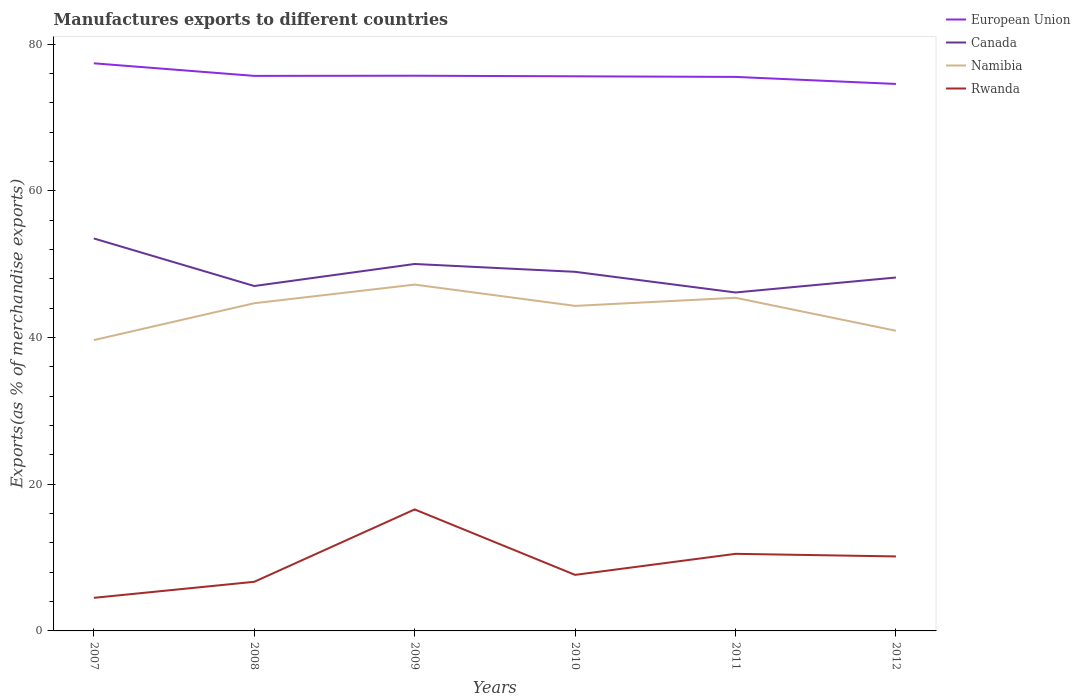How many different coloured lines are there?
Ensure brevity in your answer.  4. Does the line corresponding to Canada intersect with the line corresponding to Namibia?
Keep it short and to the point. No. Across all years, what is the maximum percentage of exports to different countries in Rwanda?
Your answer should be very brief. 4.51. What is the total percentage of exports to different countries in European Union in the graph?
Provide a short and direct response. 1.86. What is the difference between the highest and the second highest percentage of exports to different countries in Namibia?
Make the answer very short. 7.57. Is the percentage of exports to different countries in Canada strictly greater than the percentage of exports to different countries in European Union over the years?
Provide a succinct answer. Yes. Are the values on the major ticks of Y-axis written in scientific E-notation?
Provide a short and direct response. No. Does the graph contain any zero values?
Give a very brief answer. No. Does the graph contain grids?
Offer a terse response. No. Where does the legend appear in the graph?
Ensure brevity in your answer.  Top right. What is the title of the graph?
Ensure brevity in your answer.  Manufactures exports to different countries. Does "Euro area" appear as one of the legend labels in the graph?
Keep it short and to the point. No. What is the label or title of the X-axis?
Give a very brief answer. Years. What is the label or title of the Y-axis?
Give a very brief answer. Exports(as % of merchandise exports). What is the Exports(as % of merchandise exports) in European Union in 2007?
Offer a very short reply. 77.4. What is the Exports(as % of merchandise exports) in Canada in 2007?
Your answer should be compact. 53.52. What is the Exports(as % of merchandise exports) of Namibia in 2007?
Provide a short and direct response. 39.66. What is the Exports(as % of merchandise exports) of Rwanda in 2007?
Provide a short and direct response. 4.51. What is the Exports(as % of merchandise exports) in European Union in 2008?
Make the answer very short. 75.69. What is the Exports(as % of merchandise exports) in Canada in 2008?
Give a very brief answer. 47.03. What is the Exports(as % of merchandise exports) of Namibia in 2008?
Make the answer very short. 44.68. What is the Exports(as % of merchandise exports) in Rwanda in 2008?
Provide a succinct answer. 6.7. What is the Exports(as % of merchandise exports) in European Union in 2009?
Your response must be concise. 75.71. What is the Exports(as % of merchandise exports) in Canada in 2009?
Offer a very short reply. 50.04. What is the Exports(as % of merchandise exports) of Namibia in 2009?
Offer a very short reply. 47.22. What is the Exports(as % of merchandise exports) in Rwanda in 2009?
Your response must be concise. 16.57. What is the Exports(as % of merchandise exports) of European Union in 2010?
Offer a terse response. 75.63. What is the Exports(as % of merchandise exports) of Canada in 2010?
Offer a very short reply. 48.97. What is the Exports(as % of merchandise exports) in Namibia in 2010?
Your answer should be very brief. 44.32. What is the Exports(as % of merchandise exports) of Rwanda in 2010?
Provide a succinct answer. 7.64. What is the Exports(as % of merchandise exports) in European Union in 2011?
Offer a very short reply. 75.55. What is the Exports(as % of merchandise exports) in Canada in 2011?
Give a very brief answer. 46.15. What is the Exports(as % of merchandise exports) of Namibia in 2011?
Your response must be concise. 45.43. What is the Exports(as % of merchandise exports) in Rwanda in 2011?
Provide a short and direct response. 10.51. What is the Exports(as % of merchandise exports) in European Union in 2012?
Provide a succinct answer. 74.58. What is the Exports(as % of merchandise exports) of Canada in 2012?
Keep it short and to the point. 48.19. What is the Exports(as % of merchandise exports) of Namibia in 2012?
Provide a succinct answer. 40.93. What is the Exports(as % of merchandise exports) in Rwanda in 2012?
Provide a succinct answer. 10.16. Across all years, what is the maximum Exports(as % of merchandise exports) in European Union?
Offer a very short reply. 77.4. Across all years, what is the maximum Exports(as % of merchandise exports) of Canada?
Provide a short and direct response. 53.52. Across all years, what is the maximum Exports(as % of merchandise exports) in Namibia?
Offer a very short reply. 47.22. Across all years, what is the maximum Exports(as % of merchandise exports) in Rwanda?
Your answer should be very brief. 16.57. Across all years, what is the minimum Exports(as % of merchandise exports) of European Union?
Keep it short and to the point. 74.58. Across all years, what is the minimum Exports(as % of merchandise exports) in Canada?
Your answer should be compact. 46.15. Across all years, what is the minimum Exports(as % of merchandise exports) of Namibia?
Provide a short and direct response. 39.66. Across all years, what is the minimum Exports(as % of merchandise exports) of Rwanda?
Give a very brief answer. 4.51. What is the total Exports(as % of merchandise exports) in European Union in the graph?
Provide a succinct answer. 454.55. What is the total Exports(as % of merchandise exports) in Canada in the graph?
Offer a terse response. 293.9. What is the total Exports(as % of merchandise exports) of Namibia in the graph?
Offer a terse response. 262.24. What is the total Exports(as % of merchandise exports) of Rwanda in the graph?
Give a very brief answer. 56.09. What is the difference between the Exports(as % of merchandise exports) in European Union in 2007 and that in 2008?
Your answer should be compact. 1.72. What is the difference between the Exports(as % of merchandise exports) of Canada in 2007 and that in 2008?
Offer a very short reply. 6.49. What is the difference between the Exports(as % of merchandise exports) of Namibia in 2007 and that in 2008?
Your answer should be compact. -5.03. What is the difference between the Exports(as % of merchandise exports) in Rwanda in 2007 and that in 2008?
Give a very brief answer. -2.19. What is the difference between the Exports(as % of merchandise exports) of European Union in 2007 and that in 2009?
Keep it short and to the point. 1.69. What is the difference between the Exports(as % of merchandise exports) in Canada in 2007 and that in 2009?
Provide a short and direct response. 3.48. What is the difference between the Exports(as % of merchandise exports) of Namibia in 2007 and that in 2009?
Make the answer very short. -7.57. What is the difference between the Exports(as % of merchandise exports) in Rwanda in 2007 and that in 2009?
Offer a very short reply. -12.06. What is the difference between the Exports(as % of merchandise exports) of European Union in 2007 and that in 2010?
Provide a short and direct response. 1.77. What is the difference between the Exports(as % of merchandise exports) in Canada in 2007 and that in 2010?
Your answer should be compact. 4.55. What is the difference between the Exports(as % of merchandise exports) of Namibia in 2007 and that in 2010?
Offer a very short reply. -4.67. What is the difference between the Exports(as % of merchandise exports) in Rwanda in 2007 and that in 2010?
Make the answer very short. -3.13. What is the difference between the Exports(as % of merchandise exports) in European Union in 2007 and that in 2011?
Your answer should be compact. 1.86. What is the difference between the Exports(as % of merchandise exports) in Canada in 2007 and that in 2011?
Your response must be concise. 7.37. What is the difference between the Exports(as % of merchandise exports) of Namibia in 2007 and that in 2011?
Keep it short and to the point. -5.77. What is the difference between the Exports(as % of merchandise exports) of Rwanda in 2007 and that in 2011?
Your answer should be compact. -6. What is the difference between the Exports(as % of merchandise exports) in European Union in 2007 and that in 2012?
Ensure brevity in your answer.  2.82. What is the difference between the Exports(as % of merchandise exports) of Canada in 2007 and that in 2012?
Keep it short and to the point. 5.33. What is the difference between the Exports(as % of merchandise exports) in Namibia in 2007 and that in 2012?
Make the answer very short. -1.27. What is the difference between the Exports(as % of merchandise exports) of Rwanda in 2007 and that in 2012?
Ensure brevity in your answer.  -5.65. What is the difference between the Exports(as % of merchandise exports) of European Union in 2008 and that in 2009?
Keep it short and to the point. -0.02. What is the difference between the Exports(as % of merchandise exports) in Canada in 2008 and that in 2009?
Provide a short and direct response. -3. What is the difference between the Exports(as % of merchandise exports) of Namibia in 2008 and that in 2009?
Offer a very short reply. -2.54. What is the difference between the Exports(as % of merchandise exports) of Rwanda in 2008 and that in 2009?
Your answer should be very brief. -9.87. What is the difference between the Exports(as % of merchandise exports) in European Union in 2008 and that in 2010?
Your answer should be compact. 0.06. What is the difference between the Exports(as % of merchandise exports) of Canada in 2008 and that in 2010?
Offer a very short reply. -1.93. What is the difference between the Exports(as % of merchandise exports) of Namibia in 2008 and that in 2010?
Your answer should be very brief. 0.36. What is the difference between the Exports(as % of merchandise exports) of Rwanda in 2008 and that in 2010?
Give a very brief answer. -0.94. What is the difference between the Exports(as % of merchandise exports) of European Union in 2008 and that in 2011?
Give a very brief answer. 0.14. What is the difference between the Exports(as % of merchandise exports) of Canada in 2008 and that in 2011?
Your answer should be very brief. 0.88. What is the difference between the Exports(as % of merchandise exports) of Namibia in 2008 and that in 2011?
Make the answer very short. -0.74. What is the difference between the Exports(as % of merchandise exports) of Rwanda in 2008 and that in 2011?
Your answer should be compact. -3.81. What is the difference between the Exports(as % of merchandise exports) in European Union in 2008 and that in 2012?
Provide a succinct answer. 1.1. What is the difference between the Exports(as % of merchandise exports) in Canada in 2008 and that in 2012?
Ensure brevity in your answer.  -1.16. What is the difference between the Exports(as % of merchandise exports) of Namibia in 2008 and that in 2012?
Provide a short and direct response. 3.75. What is the difference between the Exports(as % of merchandise exports) of Rwanda in 2008 and that in 2012?
Your answer should be very brief. -3.46. What is the difference between the Exports(as % of merchandise exports) in European Union in 2009 and that in 2010?
Ensure brevity in your answer.  0.08. What is the difference between the Exports(as % of merchandise exports) in Canada in 2009 and that in 2010?
Give a very brief answer. 1.07. What is the difference between the Exports(as % of merchandise exports) of Namibia in 2009 and that in 2010?
Your answer should be compact. 2.9. What is the difference between the Exports(as % of merchandise exports) of Rwanda in 2009 and that in 2010?
Your answer should be very brief. 8.93. What is the difference between the Exports(as % of merchandise exports) of European Union in 2009 and that in 2011?
Make the answer very short. 0.16. What is the difference between the Exports(as % of merchandise exports) in Canada in 2009 and that in 2011?
Ensure brevity in your answer.  3.89. What is the difference between the Exports(as % of merchandise exports) of Namibia in 2009 and that in 2011?
Provide a short and direct response. 1.8. What is the difference between the Exports(as % of merchandise exports) of Rwanda in 2009 and that in 2011?
Offer a very short reply. 6.06. What is the difference between the Exports(as % of merchandise exports) in European Union in 2009 and that in 2012?
Your answer should be compact. 1.12. What is the difference between the Exports(as % of merchandise exports) of Canada in 2009 and that in 2012?
Offer a very short reply. 1.84. What is the difference between the Exports(as % of merchandise exports) in Namibia in 2009 and that in 2012?
Keep it short and to the point. 6.29. What is the difference between the Exports(as % of merchandise exports) in Rwanda in 2009 and that in 2012?
Ensure brevity in your answer.  6.41. What is the difference between the Exports(as % of merchandise exports) of European Union in 2010 and that in 2011?
Provide a short and direct response. 0.08. What is the difference between the Exports(as % of merchandise exports) of Canada in 2010 and that in 2011?
Offer a very short reply. 2.82. What is the difference between the Exports(as % of merchandise exports) of Namibia in 2010 and that in 2011?
Keep it short and to the point. -1.11. What is the difference between the Exports(as % of merchandise exports) of Rwanda in 2010 and that in 2011?
Offer a terse response. -2.87. What is the difference between the Exports(as % of merchandise exports) of European Union in 2010 and that in 2012?
Offer a terse response. 1.04. What is the difference between the Exports(as % of merchandise exports) in Canada in 2010 and that in 2012?
Your answer should be compact. 0.77. What is the difference between the Exports(as % of merchandise exports) in Namibia in 2010 and that in 2012?
Your response must be concise. 3.39. What is the difference between the Exports(as % of merchandise exports) in Rwanda in 2010 and that in 2012?
Offer a terse response. -2.52. What is the difference between the Exports(as % of merchandise exports) of European Union in 2011 and that in 2012?
Offer a very short reply. 0.96. What is the difference between the Exports(as % of merchandise exports) of Canada in 2011 and that in 2012?
Give a very brief answer. -2.04. What is the difference between the Exports(as % of merchandise exports) of Namibia in 2011 and that in 2012?
Provide a succinct answer. 4.5. What is the difference between the Exports(as % of merchandise exports) in Rwanda in 2011 and that in 2012?
Provide a short and direct response. 0.35. What is the difference between the Exports(as % of merchandise exports) in European Union in 2007 and the Exports(as % of merchandise exports) in Canada in 2008?
Your response must be concise. 30.37. What is the difference between the Exports(as % of merchandise exports) in European Union in 2007 and the Exports(as % of merchandise exports) in Namibia in 2008?
Your answer should be very brief. 32.72. What is the difference between the Exports(as % of merchandise exports) in European Union in 2007 and the Exports(as % of merchandise exports) in Rwanda in 2008?
Give a very brief answer. 70.7. What is the difference between the Exports(as % of merchandise exports) of Canada in 2007 and the Exports(as % of merchandise exports) of Namibia in 2008?
Provide a succinct answer. 8.84. What is the difference between the Exports(as % of merchandise exports) in Canada in 2007 and the Exports(as % of merchandise exports) in Rwanda in 2008?
Make the answer very short. 46.82. What is the difference between the Exports(as % of merchandise exports) in Namibia in 2007 and the Exports(as % of merchandise exports) in Rwanda in 2008?
Keep it short and to the point. 32.96. What is the difference between the Exports(as % of merchandise exports) in European Union in 2007 and the Exports(as % of merchandise exports) in Canada in 2009?
Keep it short and to the point. 27.36. What is the difference between the Exports(as % of merchandise exports) in European Union in 2007 and the Exports(as % of merchandise exports) in Namibia in 2009?
Ensure brevity in your answer.  30.18. What is the difference between the Exports(as % of merchandise exports) in European Union in 2007 and the Exports(as % of merchandise exports) in Rwanda in 2009?
Provide a succinct answer. 60.83. What is the difference between the Exports(as % of merchandise exports) in Canada in 2007 and the Exports(as % of merchandise exports) in Namibia in 2009?
Your answer should be very brief. 6.29. What is the difference between the Exports(as % of merchandise exports) of Canada in 2007 and the Exports(as % of merchandise exports) of Rwanda in 2009?
Your response must be concise. 36.95. What is the difference between the Exports(as % of merchandise exports) in Namibia in 2007 and the Exports(as % of merchandise exports) in Rwanda in 2009?
Give a very brief answer. 23.09. What is the difference between the Exports(as % of merchandise exports) of European Union in 2007 and the Exports(as % of merchandise exports) of Canada in 2010?
Offer a very short reply. 28.43. What is the difference between the Exports(as % of merchandise exports) of European Union in 2007 and the Exports(as % of merchandise exports) of Namibia in 2010?
Your answer should be compact. 33.08. What is the difference between the Exports(as % of merchandise exports) of European Union in 2007 and the Exports(as % of merchandise exports) of Rwanda in 2010?
Provide a short and direct response. 69.76. What is the difference between the Exports(as % of merchandise exports) in Canada in 2007 and the Exports(as % of merchandise exports) in Namibia in 2010?
Ensure brevity in your answer.  9.2. What is the difference between the Exports(as % of merchandise exports) in Canada in 2007 and the Exports(as % of merchandise exports) in Rwanda in 2010?
Provide a short and direct response. 45.88. What is the difference between the Exports(as % of merchandise exports) of Namibia in 2007 and the Exports(as % of merchandise exports) of Rwanda in 2010?
Ensure brevity in your answer.  32.01. What is the difference between the Exports(as % of merchandise exports) of European Union in 2007 and the Exports(as % of merchandise exports) of Canada in 2011?
Offer a very short reply. 31.25. What is the difference between the Exports(as % of merchandise exports) in European Union in 2007 and the Exports(as % of merchandise exports) in Namibia in 2011?
Ensure brevity in your answer.  31.97. What is the difference between the Exports(as % of merchandise exports) of European Union in 2007 and the Exports(as % of merchandise exports) of Rwanda in 2011?
Your response must be concise. 66.89. What is the difference between the Exports(as % of merchandise exports) in Canada in 2007 and the Exports(as % of merchandise exports) in Namibia in 2011?
Make the answer very short. 8.09. What is the difference between the Exports(as % of merchandise exports) in Canada in 2007 and the Exports(as % of merchandise exports) in Rwanda in 2011?
Make the answer very short. 43.01. What is the difference between the Exports(as % of merchandise exports) in Namibia in 2007 and the Exports(as % of merchandise exports) in Rwanda in 2011?
Keep it short and to the point. 29.14. What is the difference between the Exports(as % of merchandise exports) of European Union in 2007 and the Exports(as % of merchandise exports) of Canada in 2012?
Provide a short and direct response. 29.21. What is the difference between the Exports(as % of merchandise exports) of European Union in 2007 and the Exports(as % of merchandise exports) of Namibia in 2012?
Give a very brief answer. 36.47. What is the difference between the Exports(as % of merchandise exports) of European Union in 2007 and the Exports(as % of merchandise exports) of Rwanda in 2012?
Provide a short and direct response. 67.24. What is the difference between the Exports(as % of merchandise exports) in Canada in 2007 and the Exports(as % of merchandise exports) in Namibia in 2012?
Give a very brief answer. 12.59. What is the difference between the Exports(as % of merchandise exports) in Canada in 2007 and the Exports(as % of merchandise exports) in Rwanda in 2012?
Offer a terse response. 43.36. What is the difference between the Exports(as % of merchandise exports) in Namibia in 2007 and the Exports(as % of merchandise exports) in Rwanda in 2012?
Keep it short and to the point. 29.5. What is the difference between the Exports(as % of merchandise exports) of European Union in 2008 and the Exports(as % of merchandise exports) of Canada in 2009?
Give a very brief answer. 25.65. What is the difference between the Exports(as % of merchandise exports) in European Union in 2008 and the Exports(as % of merchandise exports) in Namibia in 2009?
Your answer should be very brief. 28.46. What is the difference between the Exports(as % of merchandise exports) in European Union in 2008 and the Exports(as % of merchandise exports) in Rwanda in 2009?
Make the answer very short. 59.12. What is the difference between the Exports(as % of merchandise exports) in Canada in 2008 and the Exports(as % of merchandise exports) in Namibia in 2009?
Offer a very short reply. -0.19. What is the difference between the Exports(as % of merchandise exports) in Canada in 2008 and the Exports(as % of merchandise exports) in Rwanda in 2009?
Ensure brevity in your answer.  30.46. What is the difference between the Exports(as % of merchandise exports) of Namibia in 2008 and the Exports(as % of merchandise exports) of Rwanda in 2009?
Provide a succinct answer. 28.12. What is the difference between the Exports(as % of merchandise exports) in European Union in 2008 and the Exports(as % of merchandise exports) in Canada in 2010?
Your answer should be very brief. 26.72. What is the difference between the Exports(as % of merchandise exports) of European Union in 2008 and the Exports(as % of merchandise exports) of Namibia in 2010?
Your answer should be very brief. 31.36. What is the difference between the Exports(as % of merchandise exports) of European Union in 2008 and the Exports(as % of merchandise exports) of Rwanda in 2010?
Provide a succinct answer. 68.04. What is the difference between the Exports(as % of merchandise exports) in Canada in 2008 and the Exports(as % of merchandise exports) in Namibia in 2010?
Your response must be concise. 2.71. What is the difference between the Exports(as % of merchandise exports) in Canada in 2008 and the Exports(as % of merchandise exports) in Rwanda in 2010?
Provide a succinct answer. 39.39. What is the difference between the Exports(as % of merchandise exports) of Namibia in 2008 and the Exports(as % of merchandise exports) of Rwanda in 2010?
Make the answer very short. 37.04. What is the difference between the Exports(as % of merchandise exports) of European Union in 2008 and the Exports(as % of merchandise exports) of Canada in 2011?
Give a very brief answer. 29.54. What is the difference between the Exports(as % of merchandise exports) of European Union in 2008 and the Exports(as % of merchandise exports) of Namibia in 2011?
Your answer should be very brief. 30.26. What is the difference between the Exports(as % of merchandise exports) in European Union in 2008 and the Exports(as % of merchandise exports) in Rwanda in 2011?
Provide a short and direct response. 65.17. What is the difference between the Exports(as % of merchandise exports) in Canada in 2008 and the Exports(as % of merchandise exports) in Namibia in 2011?
Give a very brief answer. 1.61. What is the difference between the Exports(as % of merchandise exports) of Canada in 2008 and the Exports(as % of merchandise exports) of Rwanda in 2011?
Your answer should be very brief. 36.52. What is the difference between the Exports(as % of merchandise exports) of Namibia in 2008 and the Exports(as % of merchandise exports) of Rwanda in 2011?
Provide a short and direct response. 34.17. What is the difference between the Exports(as % of merchandise exports) in European Union in 2008 and the Exports(as % of merchandise exports) in Canada in 2012?
Provide a succinct answer. 27.49. What is the difference between the Exports(as % of merchandise exports) of European Union in 2008 and the Exports(as % of merchandise exports) of Namibia in 2012?
Provide a short and direct response. 34.76. What is the difference between the Exports(as % of merchandise exports) in European Union in 2008 and the Exports(as % of merchandise exports) in Rwanda in 2012?
Keep it short and to the point. 65.53. What is the difference between the Exports(as % of merchandise exports) in Canada in 2008 and the Exports(as % of merchandise exports) in Namibia in 2012?
Make the answer very short. 6.1. What is the difference between the Exports(as % of merchandise exports) of Canada in 2008 and the Exports(as % of merchandise exports) of Rwanda in 2012?
Offer a terse response. 36.87. What is the difference between the Exports(as % of merchandise exports) in Namibia in 2008 and the Exports(as % of merchandise exports) in Rwanda in 2012?
Give a very brief answer. 34.53. What is the difference between the Exports(as % of merchandise exports) of European Union in 2009 and the Exports(as % of merchandise exports) of Canada in 2010?
Keep it short and to the point. 26.74. What is the difference between the Exports(as % of merchandise exports) of European Union in 2009 and the Exports(as % of merchandise exports) of Namibia in 2010?
Provide a short and direct response. 31.38. What is the difference between the Exports(as % of merchandise exports) of European Union in 2009 and the Exports(as % of merchandise exports) of Rwanda in 2010?
Make the answer very short. 68.06. What is the difference between the Exports(as % of merchandise exports) in Canada in 2009 and the Exports(as % of merchandise exports) in Namibia in 2010?
Ensure brevity in your answer.  5.71. What is the difference between the Exports(as % of merchandise exports) of Canada in 2009 and the Exports(as % of merchandise exports) of Rwanda in 2010?
Ensure brevity in your answer.  42.39. What is the difference between the Exports(as % of merchandise exports) in Namibia in 2009 and the Exports(as % of merchandise exports) in Rwanda in 2010?
Your response must be concise. 39.58. What is the difference between the Exports(as % of merchandise exports) in European Union in 2009 and the Exports(as % of merchandise exports) in Canada in 2011?
Ensure brevity in your answer.  29.56. What is the difference between the Exports(as % of merchandise exports) in European Union in 2009 and the Exports(as % of merchandise exports) in Namibia in 2011?
Give a very brief answer. 30.28. What is the difference between the Exports(as % of merchandise exports) in European Union in 2009 and the Exports(as % of merchandise exports) in Rwanda in 2011?
Your response must be concise. 65.2. What is the difference between the Exports(as % of merchandise exports) in Canada in 2009 and the Exports(as % of merchandise exports) in Namibia in 2011?
Make the answer very short. 4.61. What is the difference between the Exports(as % of merchandise exports) of Canada in 2009 and the Exports(as % of merchandise exports) of Rwanda in 2011?
Offer a very short reply. 39.52. What is the difference between the Exports(as % of merchandise exports) in Namibia in 2009 and the Exports(as % of merchandise exports) in Rwanda in 2011?
Your response must be concise. 36.71. What is the difference between the Exports(as % of merchandise exports) in European Union in 2009 and the Exports(as % of merchandise exports) in Canada in 2012?
Your answer should be very brief. 27.51. What is the difference between the Exports(as % of merchandise exports) in European Union in 2009 and the Exports(as % of merchandise exports) in Namibia in 2012?
Provide a succinct answer. 34.78. What is the difference between the Exports(as % of merchandise exports) in European Union in 2009 and the Exports(as % of merchandise exports) in Rwanda in 2012?
Your answer should be very brief. 65.55. What is the difference between the Exports(as % of merchandise exports) of Canada in 2009 and the Exports(as % of merchandise exports) of Namibia in 2012?
Ensure brevity in your answer.  9.11. What is the difference between the Exports(as % of merchandise exports) in Canada in 2009 and the Exports(as % of merchandise exports) in Rwanda in 2012?
Provide a short and direct response. 39.88. What is the difference between the Exports(as % of merchandise exports) in Namibia in 2009 and the Exports(as % of merchandise exports) in Rwanda in 2012?
Give a very brief answer. 37.07. What is the difference between the Exports(as % of merchandise exports) in European Union in 2010 and the Exports(as % of merchandise exports) in Canada in 2011?
Ensure brevity in your answer.  29.48. What is the difference between the Exports(as % of merchandise exports) of European Union in 2010 and the Exports(as % of merchandise exports) of Namibia in 2011?
Keep it short and to the point. 30.2. What is the difference between the Exports(as % of merchandise exports) of European Union in 2010 and the Exports(as % of merchandise exports) of Rwanda in 2011?
Make the answer very short. 65.12. What is the difference between the Exports(as % of merchandise exports) of Canada in 2010 and the Exports(as % of merchandise exports) of Namibia in 2011?
Keep it short and to the point. 3.54. What is the difference between the Exports(as % of merchandise exports) in Canada in 2010 and the Exports(as % of merchandise exports) in Rwanda in 2011?
Your answer should be very brief. 38.46. What is the difference between the Exports(as % of merchandise exports) in Namibia in 2010 and the Exports(as % of merchandise exports) in Rwanda in 2011?
Your answer should be very brief. 33.81. What is the difference between the Exports(as % of merchandise exports) in European Union in 2010 and the Exports(as % of merchandise exports) in Canada in 2012?
Your answer should be compact. 27.44. What is the difference between the Exports(as % of merchandise exports) in European Union in 2010 and the Exports(as % of merchandise exports) in Namibia in 2012?
Make the answer very short. 34.7. What is the difference between the Exports(as % of merchandise exports) of European Union in 2010 and the Exports(as % of merchandise exports) of Rwanda in 2012?
Offer a terse response. 65.47. What is the difference between the Exports(as % of merchandise exports) of Canada in 2010 and the Exports(as % of merchandise exports) of Namibia in 2012?
Give a very brief answer. 8.04. What is the difference between the Exports(as % of merchandise exports) in Canada in 2010 and the Exports(as % of merchandise exports) in Rwanda in 2012?
Your answer should be very brief. 38.81. What is the difference between the Exports(as % of merchandise exports) of Namibia in 2010 and the Exports(as % of merchandise exports) of Rwanda in 2012?
Your response must be concise. 34.16. What is the difference between the Exports(as % of merchandise exports) in European Union in 2011 and the Exports(as % of merchandise exports) in Canada in 2012?
Ensure brevity in your answer.  27.35. What is the difference between the Exports(as % of merchandise exports) in European Union in 2011 and the Exports(as % of merchandise exports) in Namibia in 2012?
Offer a very short reply. 34.62. What is the difference between the Exports(as % of merchandise exports) of European Union in 2011 and the Exports(as % of merchandise exports) of Rwanda in 2012?
Offer a terse response. 65.39. What is the difference between the Exports(as % of merchandise exports) in Canada in 2011 and the Exports(as % of merchandise exports) in Namibia in 2012?
Give a very brief answer. 5.22. What is the difference between the Exports(as % of merchandise exports) in Canada in 2011 and the Exports(as % of merchandise exports) in Rwanda in 2012?
Your answer should be very brief. 35.99. What is the difference between the Exports(as % of merchandise exports) in Namibia in 2011 and the Exports(as % of merchandise exports) in Rwanda in 2012?
Ensure brevity in your answer.  35.27. What is the average Exports(as % of merchandise exports) in European Union per year?
Keep it short and to the point. 75.76. What is the average Exports(as % of merchandise exports) of Canada per year?
Ensure brevity in your answer.  48.98. What is the average Exports(as % of merchandise exports) in Namibia per year?
Your answer should be compact. 43.71. What is the average Exports(as % of merchandise exports) in Rwanda per year?
Ensure brevity in your answer.  9.35. In the year 2007, what is the difference between the Exports(as % of merchandise exports) of European Union and Exports(as % of merchandise exports) of Canada?
Give a very brief answer. 23.88. In the year 2007, what is the difference between the Exports(as % of merchandise exports) of European Union and Exports(as % of merchandise exports) of Namibia?
Offer a very short reply. 37.74. In the year 2007, what is the difference between the Exports(as % of merchandise exports) of European Union and Exports(as % of merchandise exports) of Rwanda?
Give a very brief answer. 72.89. In the year 2007, what is the difference between the Exports(as % of merchandise exports) of Canada and Exports(as % of merchandise exports) of Namibia?
Your answer should be very brief. 13.86. In the year 2007, what is the difference between the Exports(as % of merchandise exports) in Canada and Exports(as % of merchandise exports) in Rwanda?
Offer a terse response. 49.01. In the year 2007, what is the difference between the Exports(as % of merchandise exports) of Namibia and Exports(as % of merchandise exports) of Rwanda?
Your answer should be compact. 35.14. In the year 2008, what is the difference between the Exports(as % of merchandise exports) of European Union and Exports(as % of merchandise exports) of Canada?
Offer a very short reply. 28.65. In the year 2008, what is the difference between the Exports(as % of merchandise exports) of European Union and Exports(as % of merchandise exports) of Namibia?
Keep it short and to the point. 31. In the year 2008, what is the difference between the Exports(as % of merchandise exports) of European Union and Exports(as % of merchandise exports) of Rwanda?
Offer a terse response. 68.99. In the year 2008, what is the difference between the Exports(as % of merchandise exports) in Canada and Exports(as % of merchandise exports) in Namibia?
Your response must be concise. 2.35. In the year 2008, what is the difference between the Exports(as % of merchandise exports) of Canada and Exports(as % of merchandise exports) of Rwanda?
Keep it short and to the point. 40.33. In the year 2008, what is the difference between the Exports(as % of merchandise exports) in Namibia and Exports(as % of merchandise exports) in Rwanda?
Provide a short and direct response. 37.99. In the year 2009, what is the difference between the Exports(as % of merchandise exports) in European Union and Exports(as % of merchandise exports) in Canada?
Offer a very short reply. 25.67. In the year 2009, what is the difference between the Exports(as % of merchandise exports) of European Union and Exports(as % of merchandise exports) of Namibia?
Make the answer very short. 28.48. In the year 2009, what is the difference between the Exports(as % of merchandise exports) of European Union and Exports(as % of merchandise exports) of Rwanda?
Keep it short and to the point. 59.14. In the year 2009, what is the difference between the Exports(as % of merchandise exports) in Canada and Exports(as % of merchandise exports) in Namibia?
Your answer should be very brief. 2.81. In the year 2009, what is the difference between the Exports(as % of merchandise exports) of Canada and Exports(as % of merchandise exports) of Rwanda?
Keep it short and to the point. 33.47. In the year 2009, what is the difference between the Exports(as % of merchandise exports) in Namibia and Exports(as % of merchandise exports) in Rwanda?
Your response must be concise. 30.66. In the year 2010, what is the difference between the Exports(as % of merchandise exports) of European Union and Exports(as % of merchandise exports) of Canada?
Offer a very short reply. 26.66. In the year 2010, what is the difference between the Exports(as % of merchandise exports) of European Union and Exports(as % of merchandise exports) of Namibia?
Offer a very short reply. 31.31. In the year 2010, what is the difference between the Exports(as % of merchandise exports) of European Union and Exports(as % of merchandise exports) of Rwanda?
Give a very brief answer. 67.99. In the year 2010, what is the difference between the Exports(as % of merchandise exports) in Canada and Exports(as % of merchandise exports) in Namibia?
Ensure brevity in your answer.  4.64. In the year 2010, what is the difference between the Exports(as % of merchandise exports) in Canada and Exports(as % of merchandise exports) in Rwanda?
Offer a terse response. 41.32. In the year 2010, what is the difference between the Exports(as % of merchandise exports) in Namibia and Exports(as % of merchandise exports) in Rwanda?
Your answer should be compact. 36.68. In the year 2011, what is the difference between the Exports(as % of merchandise exports) in European Union and Exports(as % of merchandise exports) in Canada?
Your answer should be very brief. 29.4. In the year 2011, what is the difference between the Exports(as % of merchandise exports) in European Union and Exports(as % of merchandise exports) in Namibia?
Offer a very short reply. 30.12. In the year 2011, what is the difference between the Exports(as % of merchandise exports) in European Union and Exports(as % of merchandise exports) in Rwanda?
Ensure brevity in your answer.  65.03. In the year 2011, what is the difference between the Exports(as % of merchandise exports) in Canada and Exports(as % of merchandise exports) in Namibia?
Provide a succinct answer. 0.72. In the year 2011, what is the difference between the Exports(as % of merchandise exports) of Canada and Exports(as % of merchandise exports) of Rwanda?
Offer a terse response. 35.64. In the year 2011, what is the difference between the Exports(as % of merchandise exports) in Namibia and Exports(as % of merchandise exports) in Rwanda?
Offer a terse response. 34.92. In the year 2012, what is the difference between the Exports(as % of merchandise exports) in European Union and Exports(as % of merchandise exports) in Canada?
Make the answer very short. 26.39. In the year 2012, what is the difference between the Exports(as % of merchandise exports) of European Union and Exports(as % of merchandise exports) of Namibia?
Give a very brief answer. 33.65. In the year 2012, what is the difference between the Exports(as % of merchandise exports) in European Union and Exports(as % of merchandise exports) in Rwanda?
Make the answer very short. 64.43. In the year 2012, what is the difference between the Exports(as % of merchandise exports) in Canada and Exports(as % of merchandise exports) in Namibia?
Keep it short and to the point. 7.26. In the year 2012, what is the difference between the Exports(as % of merchandise exports) in Canada and Exports(as % of merchandise exports) in Rwanda?
Your answer should be compact. 38.03. In the year 2012, what is the difference between the Exports(as % of merchandise exports) of Namibia and Exports(as % of merchandise exports) of Rwanda?
Ensure brevity in your answer.  30.77. What is the ratio of the Exports(as % of merchandise exports) in European Union in 2007 to that in 2008?
Provide a short and direct response. 1.02. What is the ratio of the Exports(as % of merchandise exports) in Canada in 2007 to that in 2008?
Give a very brief answer. 1.14. What is the ratio of the Exports(as % of merchandise exports) in Namibia in 2007 to that in 2008?
Give a very brief answer. 0.89. What is the ratio of the Exports(as % of merchandise exports) in Rwanda in 2007 to that in 2008?
Offer a very short reply. 0.67. What is the ratio of the Exports(as % of merchandise exports) of European Union in 2007 to that in 2009?
Give a very brief answer. 1.02. What is the ratio of the Exports(as % of merchandise exports) of Canada in 2007 to that in 2009?
Your answer should be very brief. 1.07. What is the ratio of the Exports(as % of merchandise exports) of Namibia in 2007 to that in 2009?
Give a very brief answer. 0.84. What is the ratio of the Exports(as % of merchandise exports) in Rwanda in 2007 to that in 2009?
Offer a terse response. 0.27. What is the ratio of the Exports(as % of merchandise exports) in European Union in 2007 to that in 2010?
Your response must be concise. 1.02. What is the ratio of the Exports(as % of merchandise exports) in Canada in 2007 to that in 2010?
Offer a very short reply. 1.09. What is the ratio of the Exports(as % of merchandise exports) in Namibia in 2007 to that in 2010?
Provide a short and direct response. 0.89. What is the ratio of the Exports(as % of merchandise exports) in Rwanda in 2007 to that in 2010?
Provide a short and direct response. 0.59. What is the ratio of the Exports(as % of merchandise exports) in European Union in 2007 to that in 2011?
Your answer should be compact. 1.02. What is the ratio of the Exports(as % of merchandise exports) in Canada in 2007 to that in 2011?
Keep it short and to the point. 1.16. What is the ratio of the Exports(as % of merchandise exports) of Namibia in 2007 to that in 2011?
Give a very brief answer. 0.87. What is the ratio of the Exports(as % of merchandise exports) of Rwanda in 2007 to that in 2011?
Your answer should be very brief. 0.43. What is the ratio of the Exports(as % of merchandise exports) of European Union in 2007 to that in 2012?
Your answer should be very brief. 1.04. What is the ratio of the Exports(as % of merchandise exports) of Canada in 2007 to that in 2012?
Make the answer very short. 1.11. What is the ratio of the Exports(as % of merchandise exports) of Namibia in 2007 to that in 2012?
Give a very brief answer. 0.97. What is the ratio of the Exports(as % of merchandise exports) in Rwanda in 2007 to that in 2012?
Provide a succinct answer. 0.44. What is the ratio of the Exports(as % of merchandise exports) of European Union in 2008 to that in 2009?
Your answer should be very brief. 1. What is the ratio of the Exports(as % of merchandise exports) of Namibia in 2008 to that in 2009?
Your answer should be compact. 0.95. What is the ratio of the Exports(as % of merchandise exports) in Rwanda in 2008 to that in 2009?
Keep it short and to the point. 0.4. What is the ratio of the Exports(as % of merchandise exports) in European Union in 2008 to that in 2010?
Offer a terse response. 1. What is the ratio of the Exports(as % of merchandise exports) in Canada in 2008 to that in 2010?
Your answer should be compact. 0.96. What is the ratio of the Exports(as % of merchandise exports) in Namibia in 2008 to that in 2010?
Your answer should be compact. 1.01. What is the ratio of the Exports(as % of merchandise exports) of Rwanda in 2008 to that in 2010?
Your answer should be compact. 0.88. What is the ratio of the Exports(as % of merchandise exports) of European Union in 2008 to that in 2011?
Your answer should be compact. 1. What is the ratio of the Exports(as % of merchandise exports) of Canada in 2008 to that in 2011?
Your answer should be compact. 1.02. What is the ratio of the Exports(as % of merchandise exports) of Namibia in 2008 to that in 2011?
Keep it short and to the point. 0.98. What is the ratio of the Exports(as % of merchandise exports) of Rwanda in 2008 to that in 2011?
Your answer should be compact. 0.64. What is the ratio of the Exports(as % of merchandise exports) of European Union in 2008 to that in 2012?
Your response must be concise. 1.01. What is the ratio of the Exports(as % of merchandise exports) in Canada in 2008 to that in 2012?
Your answer should be very brief. 0.98. What is the ratio of the Exports(as % of merchandise exports) of Namibia in 2008 to that in 2012?
Offer a terse response. 1.09. What is the ratio of the Exports(as % of merchandise exports) of Rwanda in 2008 to that in 2012?
Make the answer very short. 0.66. What is the ratio of the Exports(as % of merchandise exports) in Canada in 2009 to that in 2010?
Offer a terse response. 1.02. What is the ratio of the Exports(as % of merchandise exports) in Namibia in 2009 to that in 2010?
Your answer should be compact. 1.07. What is the ratio of the Exports(as % of merchandise exports) in Rwanda in 2009 to that in 2010?
Your response must be concise. 2.17. What is the ratio of the Exports(as % of merchandise exports) in Canada in 2009 to that in 2011?
Your answer should be compact. 1.08. What is the ratio of the Exports(as % of merchandise exports) of Namibia in 2009 to that in 2011?
Provide a short and direct response. 1.04. What is the ratio of the Exports(as % of merchandise exports) in Rwanda in 2009 to that in 2011?
Provide a succinct answer. 1.58. What is the ratio of the Exports(as % of merchandise exports) in European Union in 2009 to that in 2012?
Your response must be concise. 1.02. What is the ratio of the Exports(as % of merchandise exports) of Canada in 2009 to that in 2012?
Give a very brief answer. 1.04. What is the ratio of the Exports(as % of merchandise exports) in Namibia in 2009 to that in 2012?
Offer a very short reply. 1.15. What is the ratio of the Exports(as % of merchandise exports) in Rwanda in 2009 to that in 2012?
Ensure brevity in your answer.  1.63. What is the ratio of the Exports(as % of merchandise exports) in European Union in 2010 to that in 2011?
Give a very brief answer. 1. What is the ratio of the Exports(as % of merchandise exports) in Canada in 2010 to that in 2011?
Your answer should be very brief. 1.06. What is the ratio of the Exports(as % of merchandise exports) in Namibia in 2010 to that in 2011?
Provide a short and direct response. 0.98. What is the ratio of the Exports(as % of merchandise exports) of Rwanda in 2010 to that in 2011?
Give a very brief answer. 0.73. What is the ratio of the Exports(as % of merchandise exports) of European Union in 2010 to that in 2012?
Provide a succinct answer. 1.01. What is the ratio of the Exports(as % of merchandise exports) in Canada in 2010 to that in 2012?
Offer a terse response. 1.02. What is the ratio of the Exports(as % of merchandise exports) in Namibia in 2010 to that in 2012?
Give a very brief answer. 1.08. What is the ratio of the Exports(as % of merchandise exports) of Rwanda in 2010 to that in 2012?
Keep it short and to the point. 0.75. What is the ratio of the Exports(as % of merchandise exports) in European Union in 2011 to that in 2012?
Make the answer very short. 1.01. What is the ratio of the Exports(as % of merchandise exports) in Canada in 2011 to that in 2012?
Provide a short and direct response. 0.96. What is the ratio of the Exports(as % of merchandise exports) of Namibia in 2011 to that in 2012?
Offer a very short reply. 1.11. What is the ratio of the Exports(as % of merchandise exports) of Rwanda in 2011 to that in 2012?
Provide a short and direct response. 1.03. What is the difference between the highest and the second highest Exports(as % of merchandise exports) of European Union?
Offer a very short reply. 1.69. What is the difference between the highest and the second highest Exports(as % of merchandise exports) in Canada?
Provide a succinct answer. 3.48. What is the difference between the highest and the second highest Exports(as % of merchandise exports) of Namibia?
Make the answer very short. 1.8. What is the difference between the highest and the second highest Exports(as % of merchandise exports) of Rwanda?
Your answer should be compact. 6.06. What is the difference between the highest and the lowest Exports(as % of merchandise exports) of European Union?
Keep it short and to the point. 2.82. What is the difference between the highest and the lowest Exports(as % of merchandise exports) of Canada?
Your answer should be very brief. 7.37. What is the difference between the highest and the lowest Exports(as % of merchandise exports) of Namibia?
Ensure brevity in your answer.  7.57. What is the difference between the highest and the lowest Exports(as % of merchandise exports) in Rwanda?
Your answer should be compact. 12.06. 